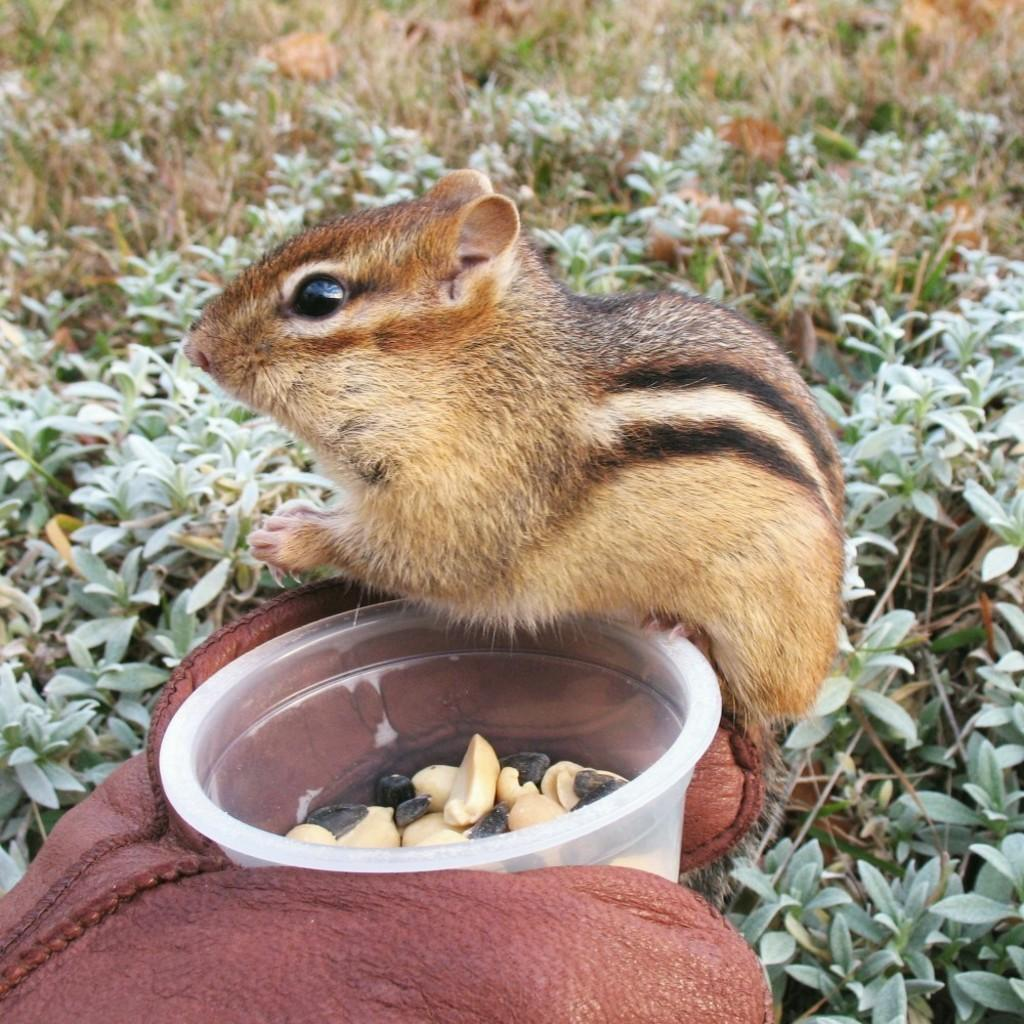What type of animal can be seen in the image? There is a squirrel in the image. What is the squirrel interacting with in the image? The squirrel is interacting with nuts in a plastic bowl in the image. What can be seen in the background of the image? There are plants visible in the background of the image. How does the squirrel cause trouble with the cannon in the image? There is no cannon present in the image, and therefore no interaction between the squirrel and a cannon can be observed. 